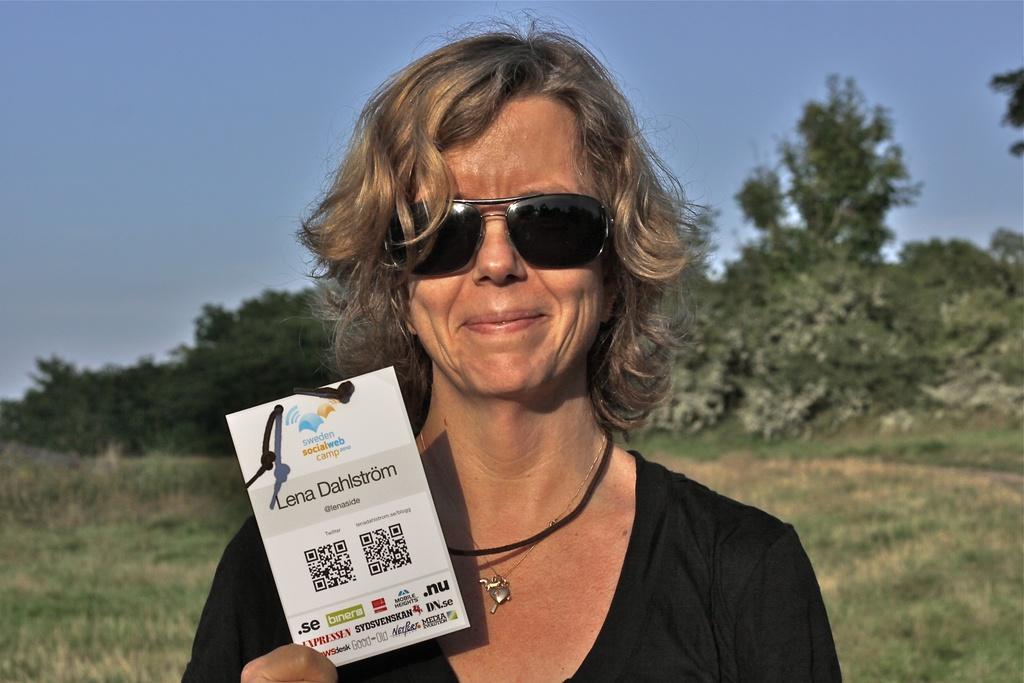How would you summarize this image in a sentence or two? In this image we can see a woman standing and holding a card with some text and in the background we can see some trees and grass on the ground. At the top, we can see the sky. 